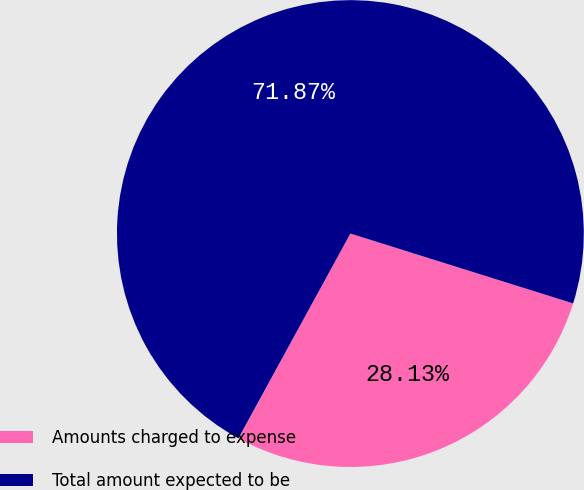Convert chart to OTSL. <chart><loc_0><loc_0><loc_500><loc_500><pie_chart><fcel>Amounts charged to expense<fcel>Total amount expected to be<nl><fcel>28.13%<fcel>71.87%<nl></chart> 